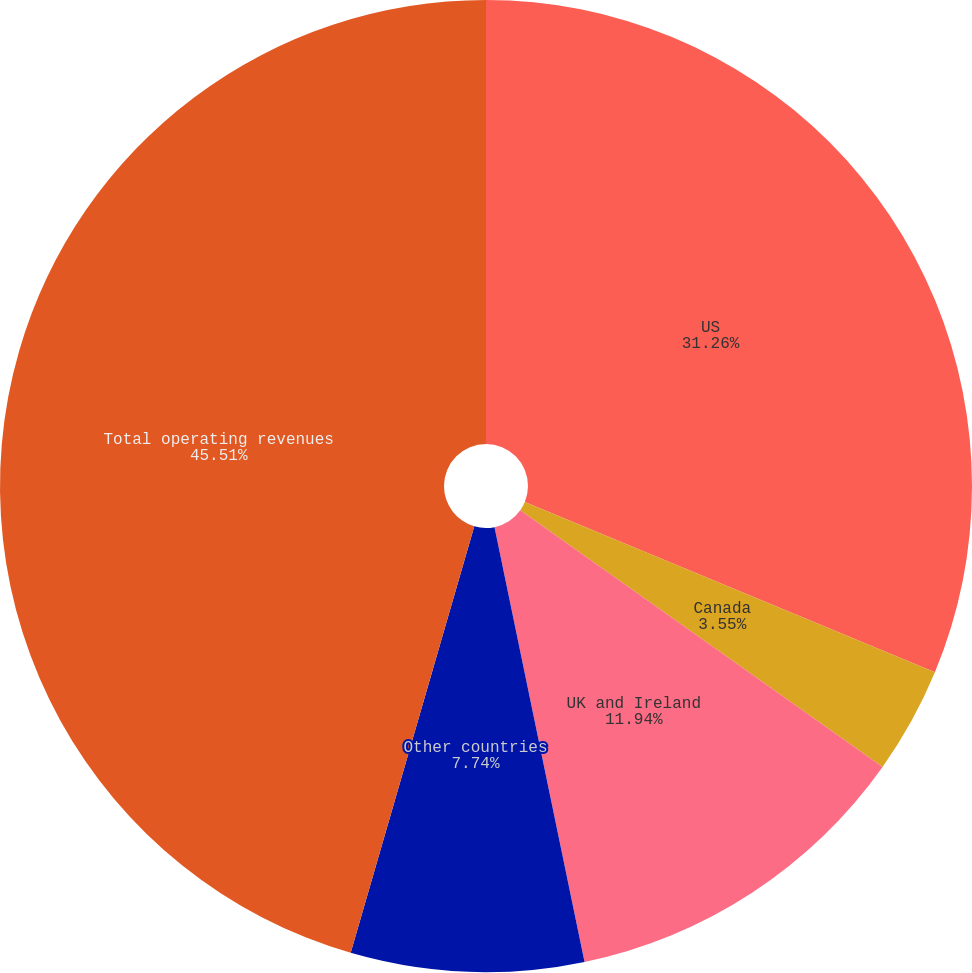Convert chart to OTSL. <chart><loc_0><loc_0><loc_500><loc_500><pie_chart><fcel>US<fcel>Canada<fcel>UK and Ireland<fcel>Other countries<fcel>Total operating revenues<nl><fcel>31.26%<fcel>3.55%<fcel>11.94%<fcel>7.74%<fcel>45.51%<nl></chart> 